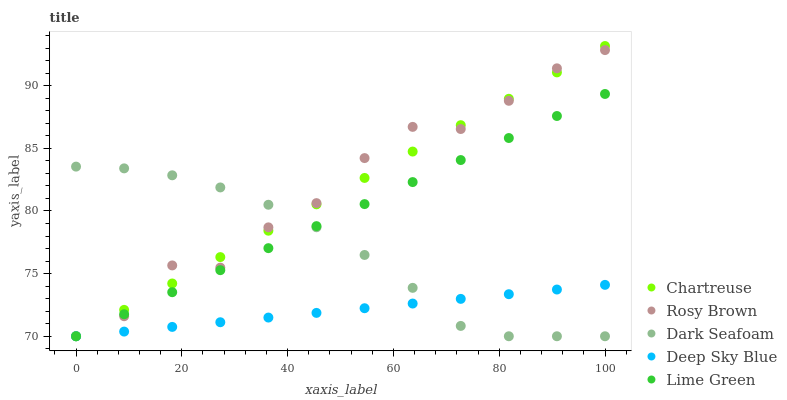Does Deep Sky Blue have the minimum area under the curve?
Answer yes or no. Yes. Does Rosy Brown have the maximum area under the curve?
Answer yes or no. Yes. Does Lime Green have the minimum area under the curve?
Answer yes or no. No. Does Lime Green have the maximum area under the curve?
Answer yes or no. No. Is Deep Sky Blue the smoothest?
Answer yes or no. Yes. Is Rosy Brown the roughest?
Answer yes or no. Yes. Is Lime Green the smoothest?
Answer yes or no. No. Is Lime Green the roughest?
Answer yes or no. No. Does Chartreuse have the lowest value?
Answer yes or no. Yes. Does Chartreuse have the highest value?
Answer yes or no. Yes. Does Rosy Brown have the highest value?
Answer yes or no. No. Does Deep Sky Blue intersect Lime Green?
Answer yes or no. Yes. Is Deep Sky Blue less than Lime Green?
Answer yes or no. No. Is Deep Sky Blue greater than Lime Green?
Answer yes or no. No. 